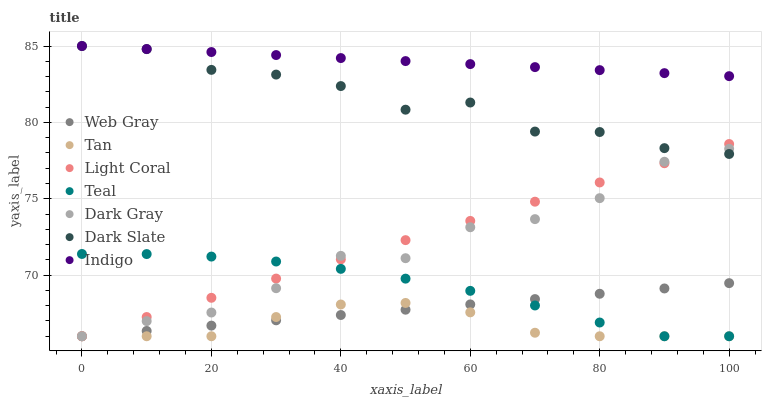Does Tan have the minimum area under the curve?
Answer yes or no. Yes. Does Indigo have the maximum area under the curve?
Answer yes or no. Yes. Does Web Gray have the minimum area under the curve?
Answer yes or no. No. Does Web Gray have the maximum area under the curve?
Answer yes or no. No. Is Indigo the smoothest?
Answer yes or no. Yes. Is Dark Slate the roughest?
Answer yes or no. Yes. Is Web Gray the smoothest?
Answer yes or no. No. Is Web Gray the roughest?
Answer yes or no. No. Does Dark Gray have the lowest value?
Answer yes or no. Yes. Does Indigo have the lowest value?
Answer yes or no. No. Does Dark Slate have the highest value?
Answer yes or no. Yes. Does Web Gray have the highest value?
Answer yes or no. No. Is Teal less than Indigo?
Answer yes or no. Yes. Is Indigo greater than Tan?
Answer yes or no. Yes. Does Web Gray intersect Dark Gray?
Answer yes or no. Yes. Is Web Gray less than Dark Gray?
Answer yes or no. No. Is Web Gray greater than Dark Gray?
Answer yes or no. No. Does Teal intersect Indigo?
Answer yes or no. No. 